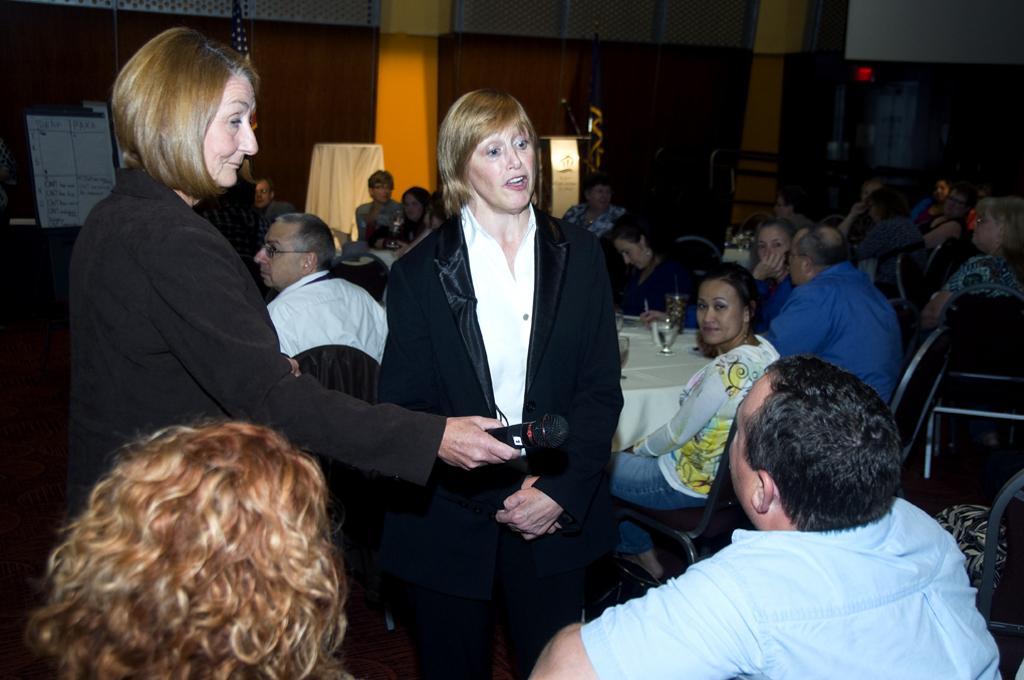Could you give a brief overview of what you see in this image? In this image there are many people sitting on the chairs at the tables. On the tables there are glasses. In the foreground there are two women standing. The woman to the left is holding a microphone in her hand. In the background there is the wall. To the left there is a board near to the wall. 